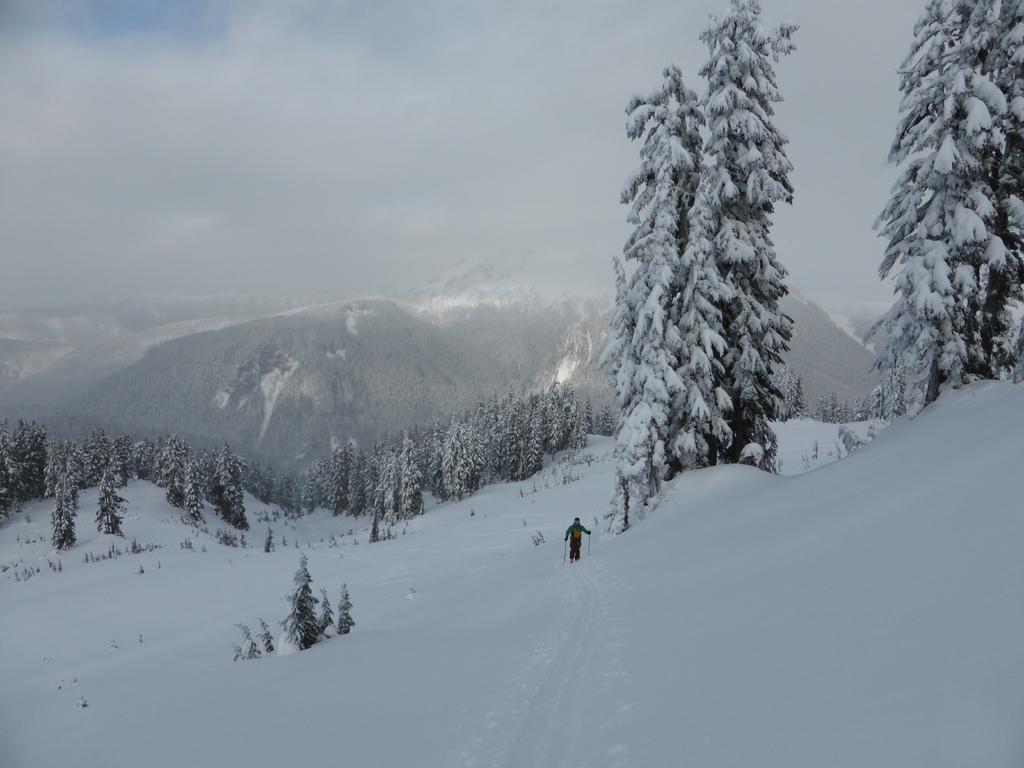Could you give a brief overview of what you see in this image? In this image we can see a person skiing on the snow. In the background there is a hills, trees, snow, sky and clouds. 